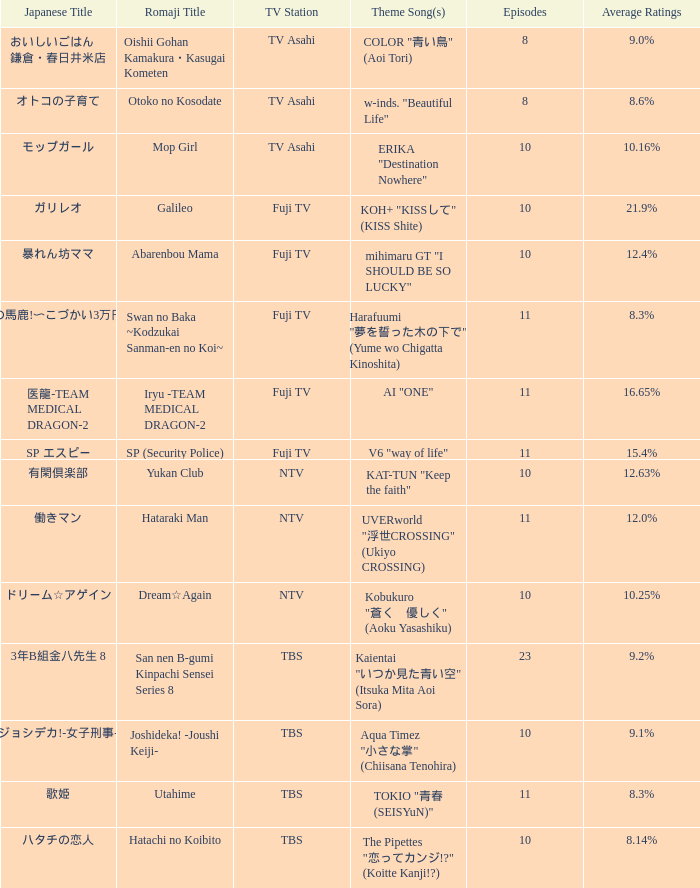What is the signature tune of the yukan club? KAT-TUN "Keep the faith". 